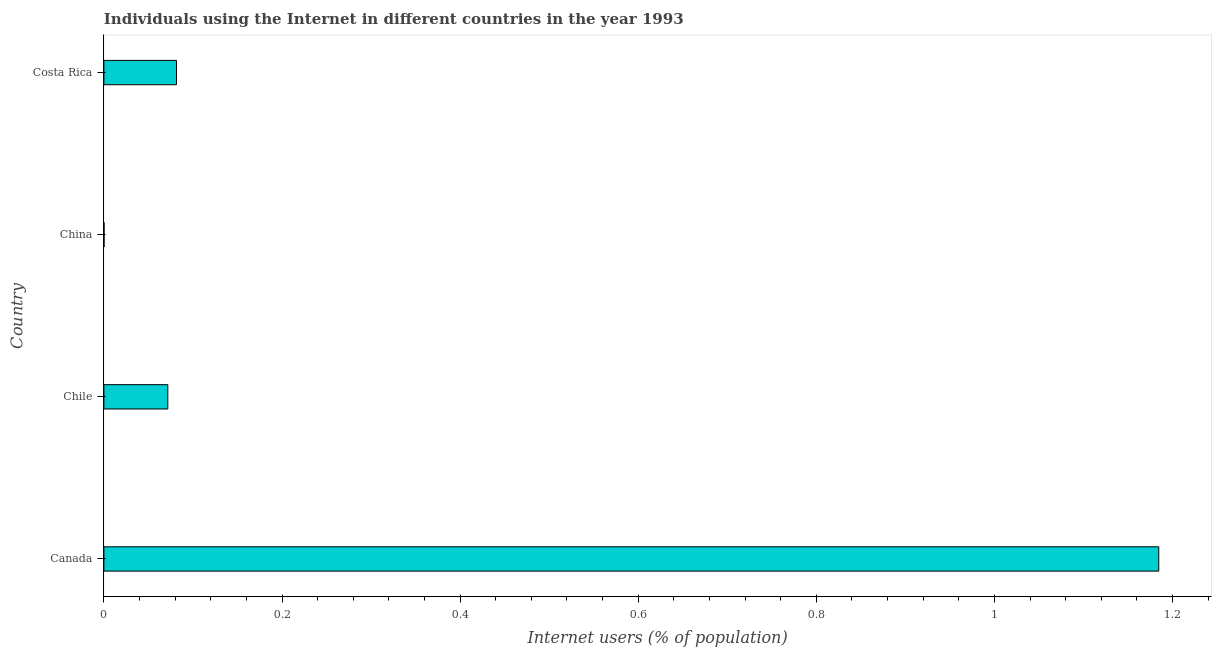Does the graph contain any zero values?
Keep it short and to the point. No. Does the graph contain grids?
Offer a terse response. No. What is the title of the graph?
Keep it short and to the point. Individuals using the Internet in different countries in the year 1993. What is the label or title of the X-axis?
Give a very brief answer. Internet users (% of population). What is the number of internet users in China?
Give a very brief answer. 0. Across all countries, what is the maximum number of internet users?
Keep it short and to the point. 1.18. Across all countries, what is the minimum number of internet users?
Offer a terse response. 0. What is the sum of the number of internet users?
Ensure brevity in your answer.  1.34. What is the difference between the number of internet users in Chile and Costa Rica?
Offer a very short reply. -0.01. What is the average number of internet users per country?
Provide a succinct answer. 0.34. What is the median number of internet users?
Ensure brevity in your answer.  0.08. In how many countries, is the number of internet users greater than 0.52 %?
Provide a succinct answer. 1. What is the ratio of the number of internet users in Chile to that in Costa Rica?
Ensure brevity in your answer.  0.88. Is the number of internet users in Canada less than that in China?
Ensure brevity in your answer.  No. What is the difference between the highest and the second highest number of internet users?
Your answer should be very brief. 1.1. Is the sum of the number of internet users in Canada and Chile greater than the maximum number of internet users across all countries?
Ensure brevity in your answer.  Yes. What is the difference between the highest and the lowest number of internet users?
Your answer should be compact. 1.18. In how many countries, is the number of internet users greater than the average number of internet users taken over all countries?
Keep it short and to the point. 1. How many bars are there?
Your answer should be very brief. 4. Are all the bars in the graph horizontal?
Your answer should be compact. Yes. What is the Internet users (% of population) in Canada?
Your answer should be very brief. 1.18. What is the Internet users (% of population) in Chile?
Provide a succinct answer. 0.07. What is the Internet users (% of population) of China?
Your answer should be compact. 0. What is the Internet users (% of population) in Costa Rica?
Offer a very short reply. 0.08. What is the difference between the Internet users (% of population) in Canada and Chile?
Offer a very short reply. 1.11. What is the difference between the Internet users (% of population) in Canada and China?
Your answer should be compact. 1.18. What is the difference between the Internet users (% of population) in Canada and Costa Rica?
Offer a very short reply. 1.1. What is the difference between the Internet users (% of population) in Chile and China?
Your response must be concise. 0.07. What is the difference between the Internet users (% of population) in Chile and Costa Rica?
Give a very brief answer. -0.01. What is the difference between the Internet users (% of population) in China and Costa Rica?
Your response must be concise. -0.08. What is the ratio of the Internet users (% of population) in Canada to that in Chile?
Make the answer very short. 16.5. What is the ratio of the Internet users (% of population) in Canada to that in China?
Your response must be concise. 7022.5. What is the ratio of the Internet users (% of population) in Canada to that in Costa Rica?
Give a very brief answer. 14.53. What is the ratio of the Internet users (% of population) in Chile to that in China?
Make the answer very short. 425.56. What is the ratio of the Internet users (% of population) in Chile to that in Costa Rica?
Make the answer very short. 0.88. What is the ratio of the Internet users (% of population) in China to that in Costa Rica?
Make the answer very short. 0. 